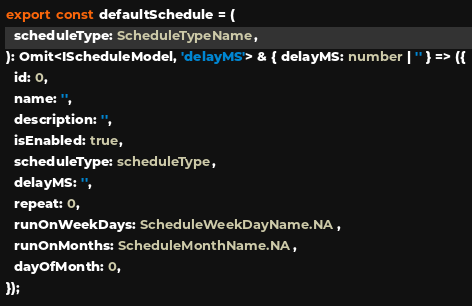<code> <loc_0><loc_0><loc_500><loc_500><_TypeScript_>export const defaultSchedule = (
  scheduleType: ScheduleTypeName,
): Omit<IScheduleModel, 'delayMS'> & { delayMS: number | '' } => ({
  id: 0,
  name: '',
  description: '',
  isEnabled: true,
  scheduleType: scheduleType,
  delayMS: '',
  repeat: 0,
  runOnWeekDays: ScheduleWeekDayName.NA,
  runOnMonths: ScheduleMonthName.NA,
  dayOfMonth: 0,
});
</code> 